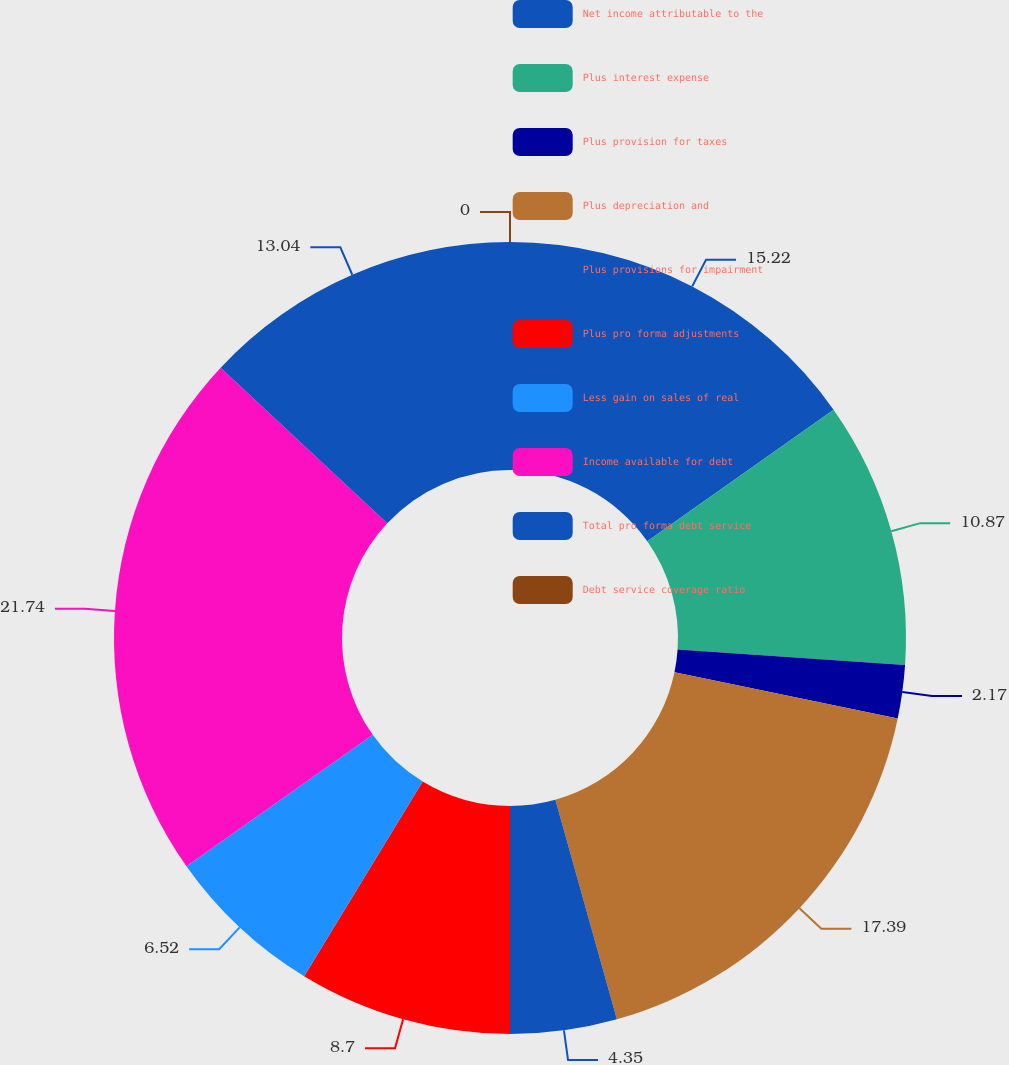<chart> <loc_0><loc_0><loc_500><loc_500><pie_chart><fcel>Net income attributable to the<fcel>Plus interest expense<fcel>Plus provision for taxes<fcel>Plus depreciation and<fcel>Plus provisions for impairment<fcel>Plus pro forma adjustments<fcel>Less gain on sales of real<fcel>Income available for debt<fcel>Total pro forma debt service<fcel>Debt service coverage ratio<nl><fcel>15.22%<fcel>10.87%<fcel>2.17%<fcel>17.39%<fcel>4.35%<fcel>8.7%<fcel>6.52%<fcel>21.74%<fcel>13.04%<fcel>0.0%<nl></chart> 